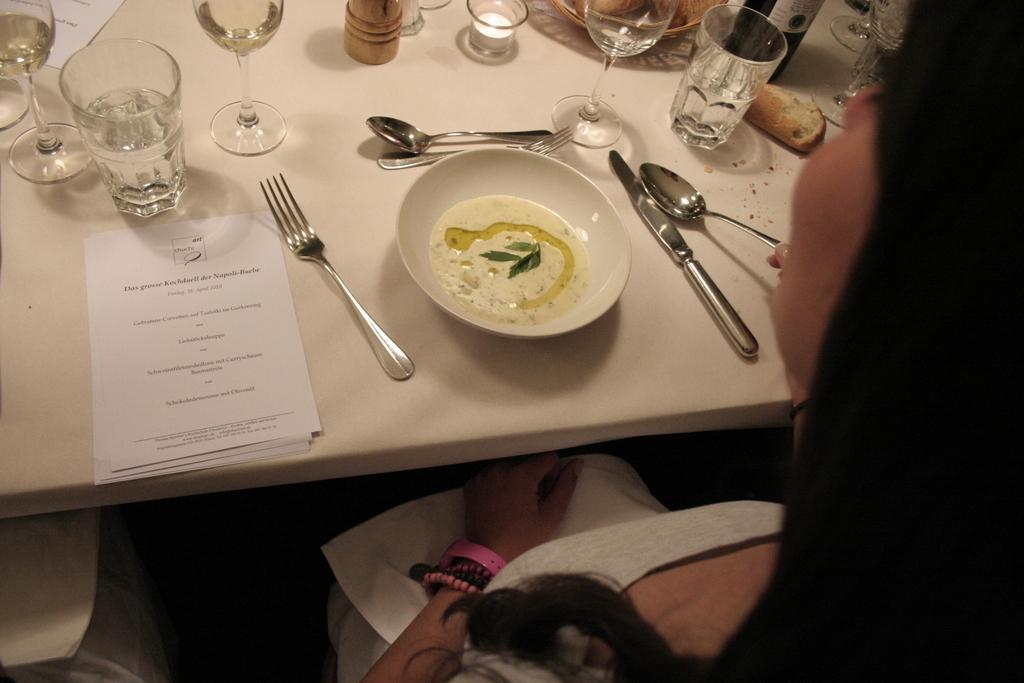In one or two sentences, can you explain what this image depicts? In this image I can see a person and a table. On this table I can see number of spoons, a plate, few glasses and a paper. 